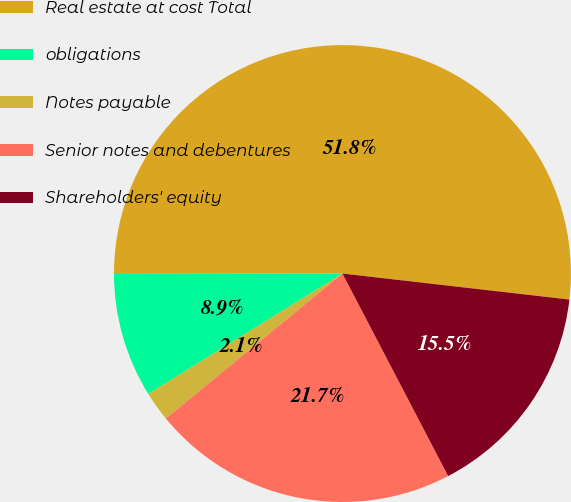<chart> <loc_0><loc_0><loc_500><loc_500><pie_chart><fcel>Real estate at cost Total<fcel>obligations<fcel>Notes payable<fcel>Senior notes and debentures<fcel>Shareholders' equity<nl><fcel>51.79%<fcel>8.87%<fcel>2.1%<fcel>21.72%<fcel>15.53%<nl></chart> 